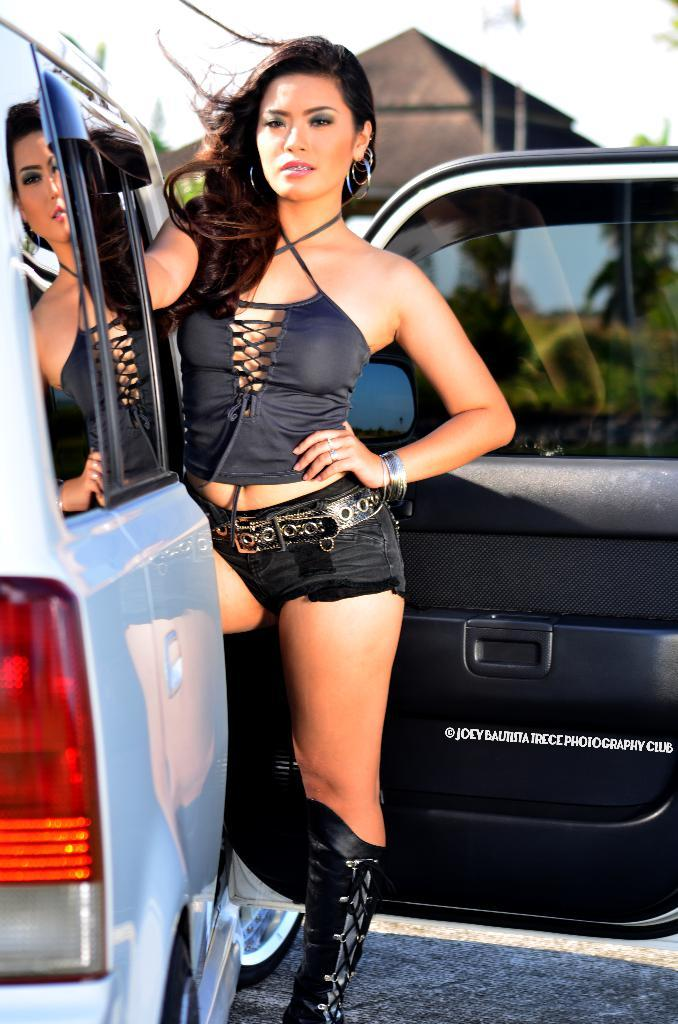What is the woman doing in the image? The woman is standing near a vehicle in the image. What can be seen in the background of the image? There is a house and plants in the background of the image. What type of sweater is the woman wearing while reading a twist in the image? There is no sweater, reading, or twist present in the image. 